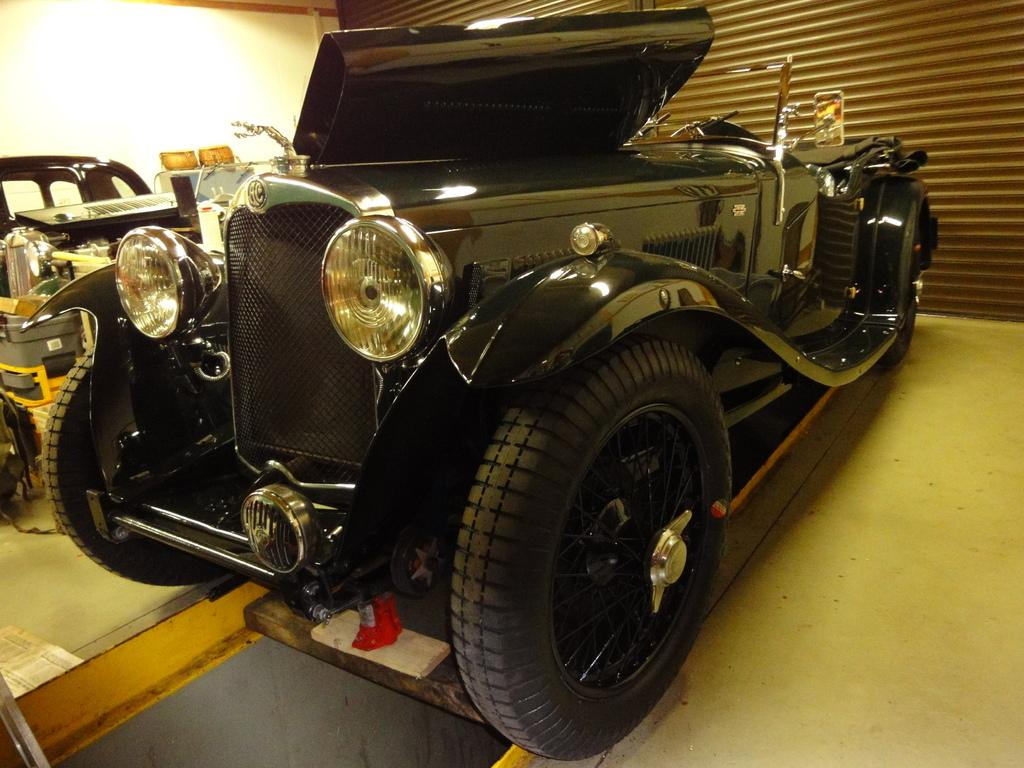What types of objects are present in the image? There are vehicles in the image. What is blocking the view of the vehicles? There is a shutter in front of the vehicles. What can be seen on the left side of the image? There is a wall on the left side of the image. What type of coat is hanging on the wall in the image? There is no coat present in the image; only vehicles, a shutter, and a wall are visible. Can you hear any harmonious sounds in the image? The image is a still picture, so there are no sounds present, let alone harmonious ones. 